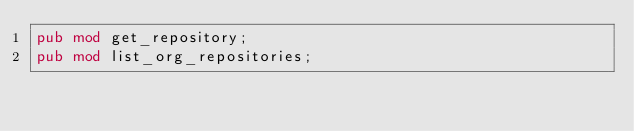Convert code to text. <code><loc_0><loc_0><loc_500><loc_500><_Rust_>pub mod get_repository;
pub mod list_org_repositories;
</code> 